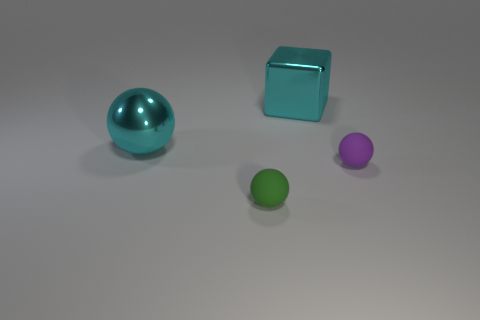Add 1 tiny green objects. How many objects exist? 5 Subtract all spheres. How many objects are left? 1 Add 2 big metal objects. How many big metal objects exist? 4 Subtract 0 blue cubes. How many objects are left? 4 Subtract all large cyan blocks. Subtract all large cyan cubes. How many objects are left? 2 Add 2 tiny balls. How many tiny balls are left? 4 